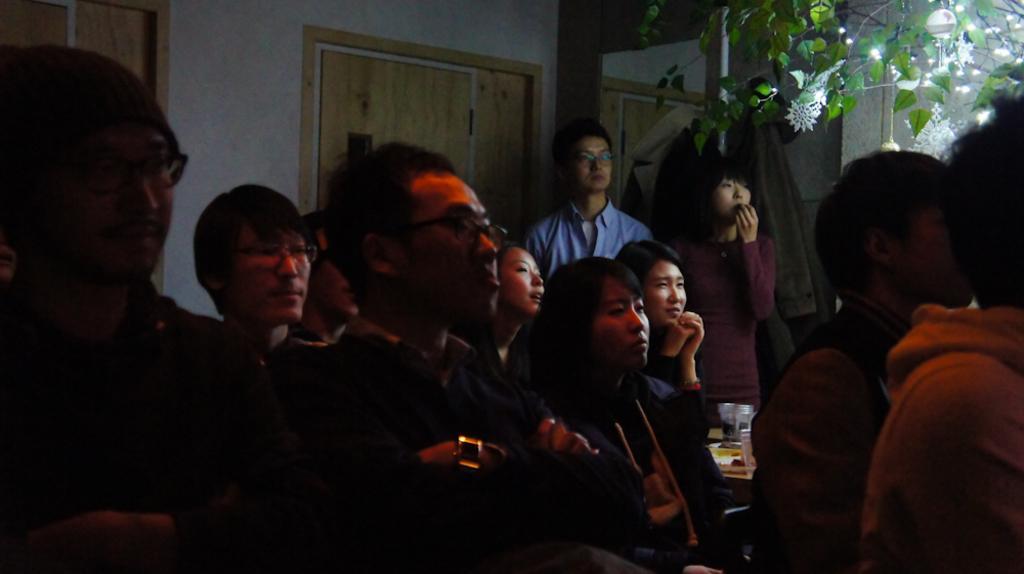Please provide a concise description of this image. In this picture I can see number of people and in the background I see the wall and on the right side of this image I see the leaves and the lights and I see few white color things. 